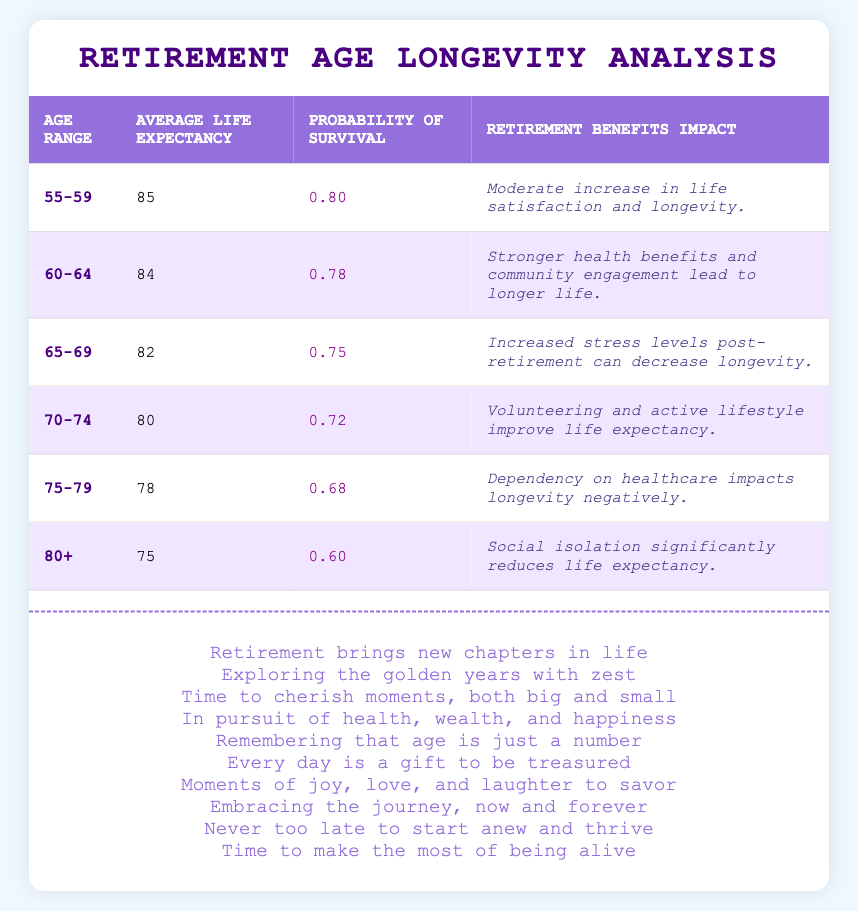What is the average life expectancy for the age group 60-64? According to the table, the average life expectancy for the age range 60-64 is explicitly listed as 84.
Answer: 84 What is the probability of survival to age for the age group 70-74? The table shows that the probability of survival to age for the age range 70-74 is 0.72.
Answer: 0.72 Is there a higher average life expectancy for those aged 55-59 compared to those aged 75-79? Yes, the average life expectancy for 55-59 is 85, while for 75-79 it is 78. Since 85 is greater than 78, the statement is true.
Answer: Yes What is the difference in average life expectancy between the age groups 65-69 and 70-74? The average life expectancy for 65-69 is 82 and for 70-74 is 80. The difference is calculated as 82 - 80 = 2.
Answer: 2 What impact does retirement have on longevity for age group 80+? The retirement benefits impact for the age group 80+ is stated as "Social isolation significantly reduces life expectancy." This indicates a negative impact.
Answer: Negative impact If a person in the 60-64 age group has a probability of survival of 0.78, what is the likelihood of not surviving to that age? The probability of not surviving is calculated as 1 - Probability of survival. Thus, 1 - 0.78 = 0.22.
Answer: 0.22 Which age group has the lowest probability of survival to age? The age group 80+ has a probability of survival of 0.60, which is the lowest value in the table. All other age groups have higher probabilities.
Answer: 80+ What is the average life expectancy for individuals aged 75-79? From the table, the average life expectancy for the age group 75-79 is clearly stated as 78.
Answer: 78 What common benefit do individuals in the age group 70-74 experience, according to the table? The table notes that "Volunteering and active lifestyle improve life expectancy" for the age group 70-74, indicating that maintaining activity and community engagement contributes positively.
Answer: Improved life expectancy 